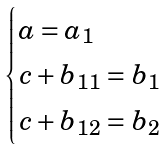Convert formula to latex. <formula><loc_0><loc_0><loc_500><loc_500>\begin{cases} a = a _ { 1 } \\ c + b _ { 1 1 } = b _ { 1 } \\ c + b _ { 1 2 } = b _ { 2 } \end{cases}</formula> 